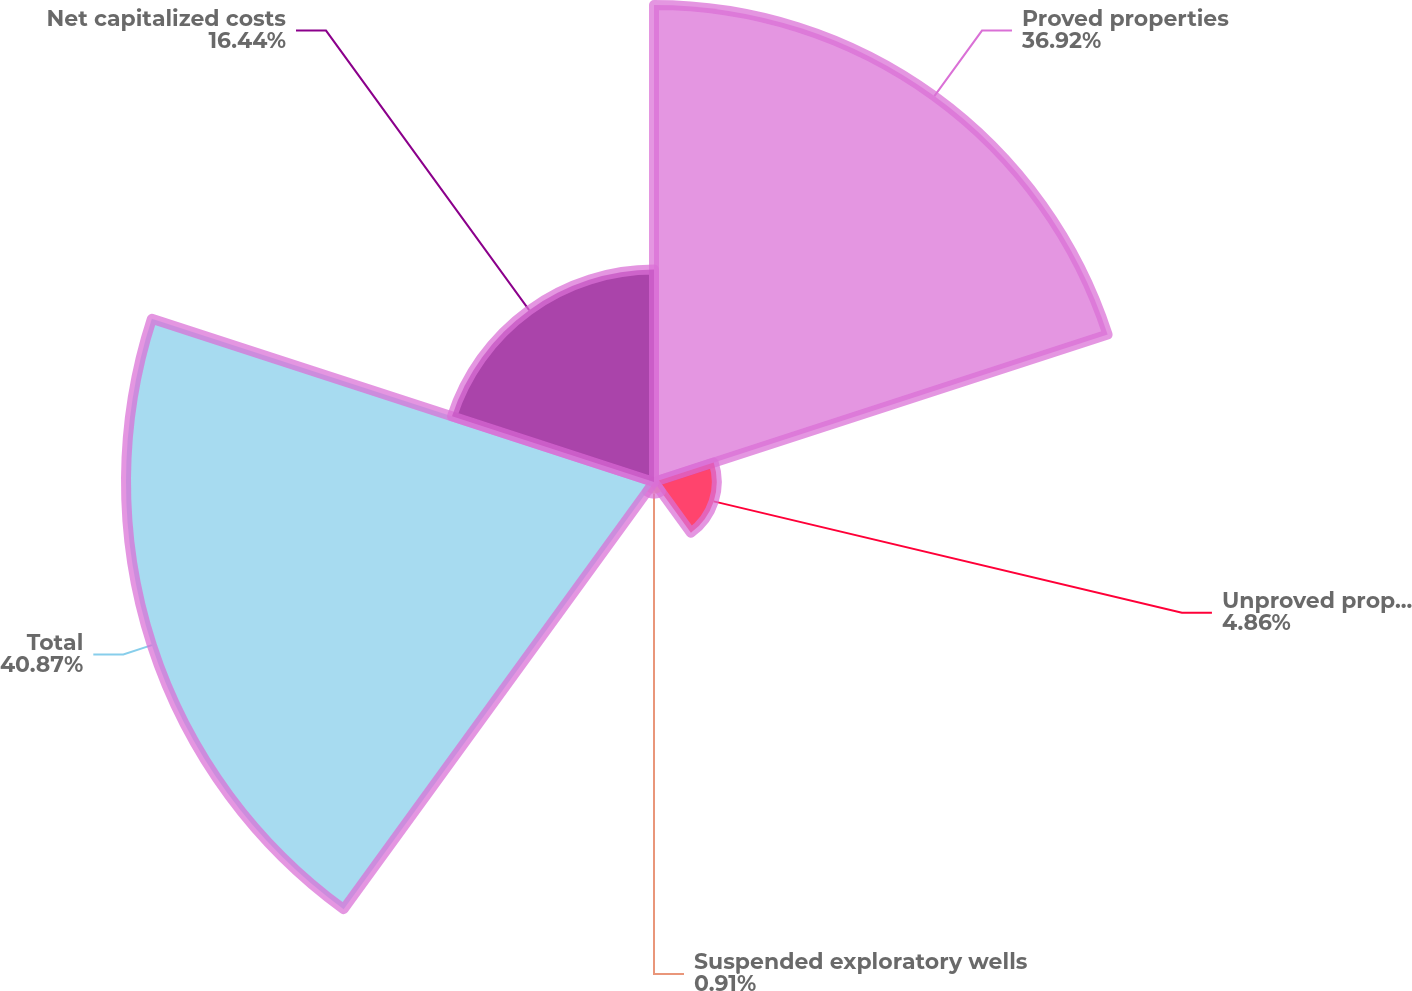Convert chart. <chart><loc_0><loc_0><loc_500><loc_500><pie_chart><fcel>Proved properties<fcel>Unproved properties<fcel>Suspended exploratory wells<fcel>Total<fcel>Net capitalized costs<nl><fcel>36.92%<fcel>4.86%<fcel>0.91%<fcel>40.87%<fcel>16.44%<nl></chart> 